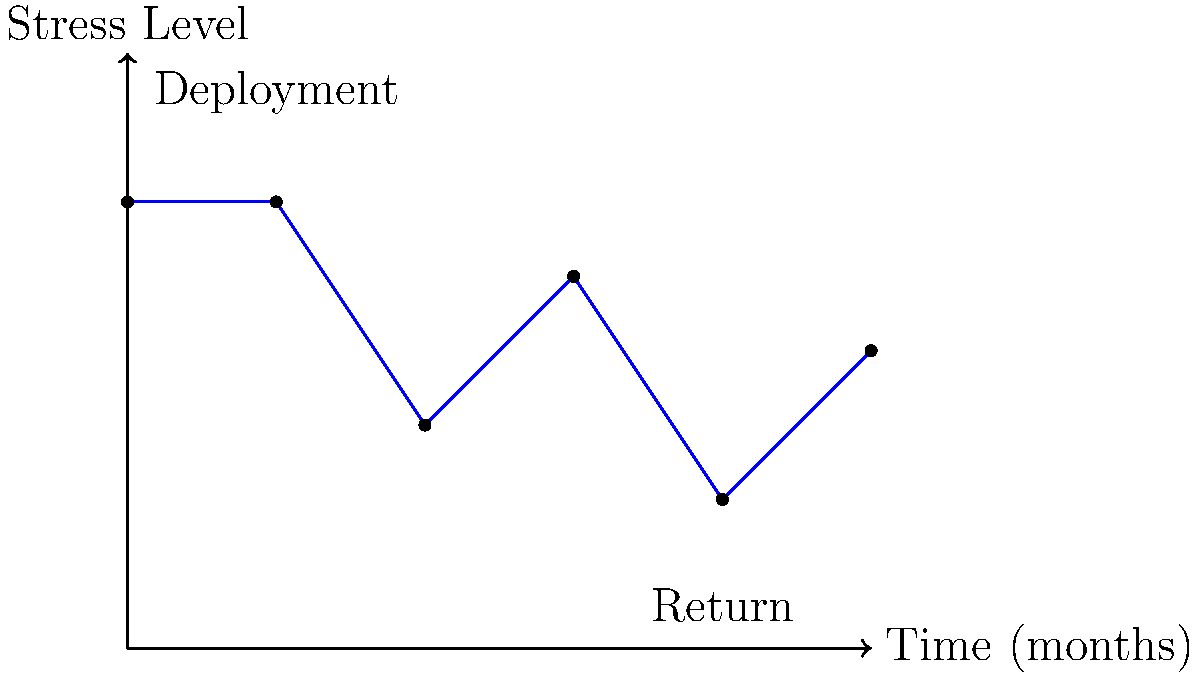Based on the time-series graph showing stress levels in a military family over a 10-month period, which includes a deployment and return, estimate the overall psychological impact of the deployment cycle. Consider the stress level changes and family dynamics represented by the blue line. To estimate the overall psychological impact of the deployment cycle, we need to analyze the stress levels throughout the 10-month period:

1. Initial stress level (0 months): The family starts at a relatively high stress level (6 units).

2. Deployment (2 months): Stress remains high, indicating the immediate impact of separation.

3. Mid-deployment (4 months): Stress decreases to 3 units, suggesting adaptation to the new situation.

4. Late deployment (6 months): Stress increases to 5 units, possibly due to prolonged separation and anticipation of return.

5. Return (8 months): Stress drops sharply to 2 units, indicating initial relief and happiness.

6. Post-return (10 months): Stress increases to 4 units, suggesting challenges in readjustment.

To quantify the overall impact:

1. Calculate the average stress level: $\frac{6 + 6 + 3 + 5 + 2 + 4}{6} = 4.33$

2. Compare to initial stress level: $4.33 - 6 = -1.67$

3. Consider the volatility: High fluctuations indicate significant emotional strain.

4. Long-term trend: Final stress level (4) is lower than initial (6), suggesting some positive adaptation.

The overall psychological impact can be estimated as moderate to high, with significant stress fluctuations but eventual partial recovery.
Answer: Moderate to high impact with eventual partial recovery 